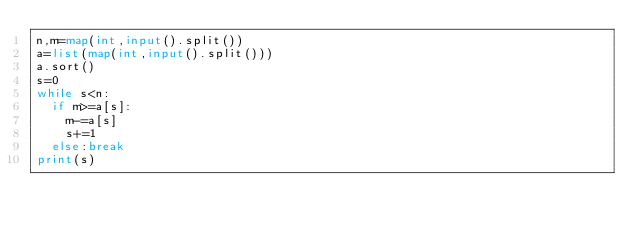<code> <loc_0><loc_0><loc_500><loc_500><_Python_>n,m=map(int,input().split())
a=list(map(int,input().split()))
a.sort()
s=0
while s<n:
  if m>=a[s]:
    m-=a[s]
    s+=1
  else:break
print(s)</code> 